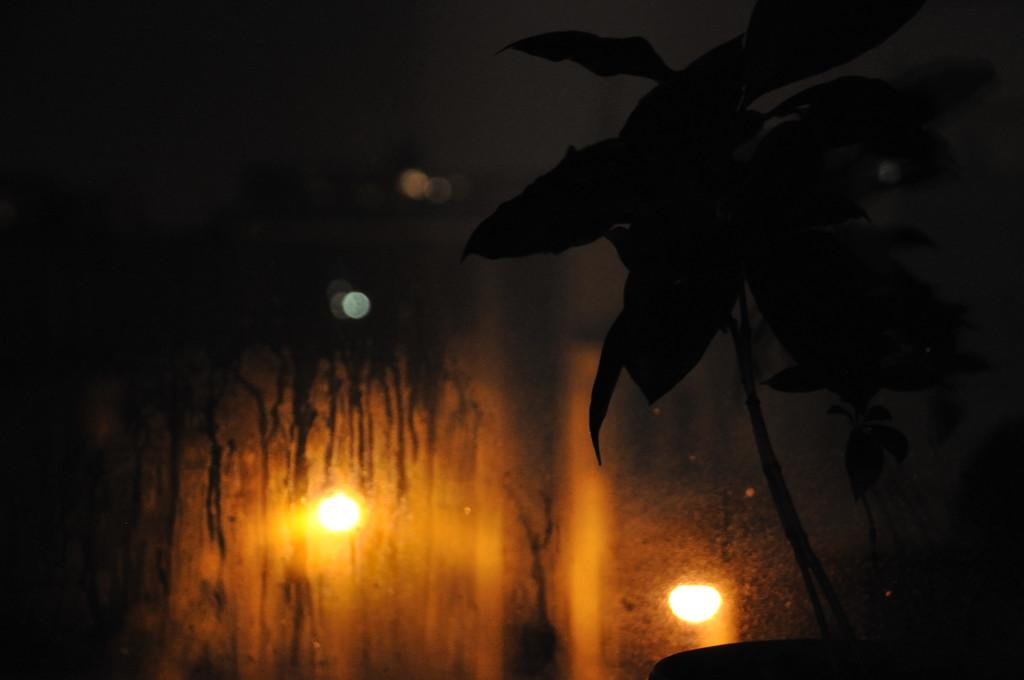What type of living organism can be seen in the image? There is a plant in the image. What object is also present in the image? There is a glass in the image. What is inside the glass? The glass contains lights. How would you describe the overall lighting in the image? The background of the image is dark. Can you see a flock of animals in the image? There is no flock of animals present in the image. What type of tail can be seen on the plant in the image? There is no tail present on the plant in the image, as plants do not have tails. 